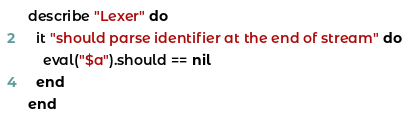<code> <loc_0><loc_0><loc_500><loc_500><_Ruby_>describe "Lexer" do
  it "should parse identifier at the end of stream" do
    eval("$a").should == nil
  end
end
</code> 